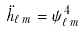<formula> <loc_0><loc_0><loc_500><loc_500>\ddot { h } _ { \ell \, m } = \psi ^ { 4 } _ { \ell \, m } \</formula> 